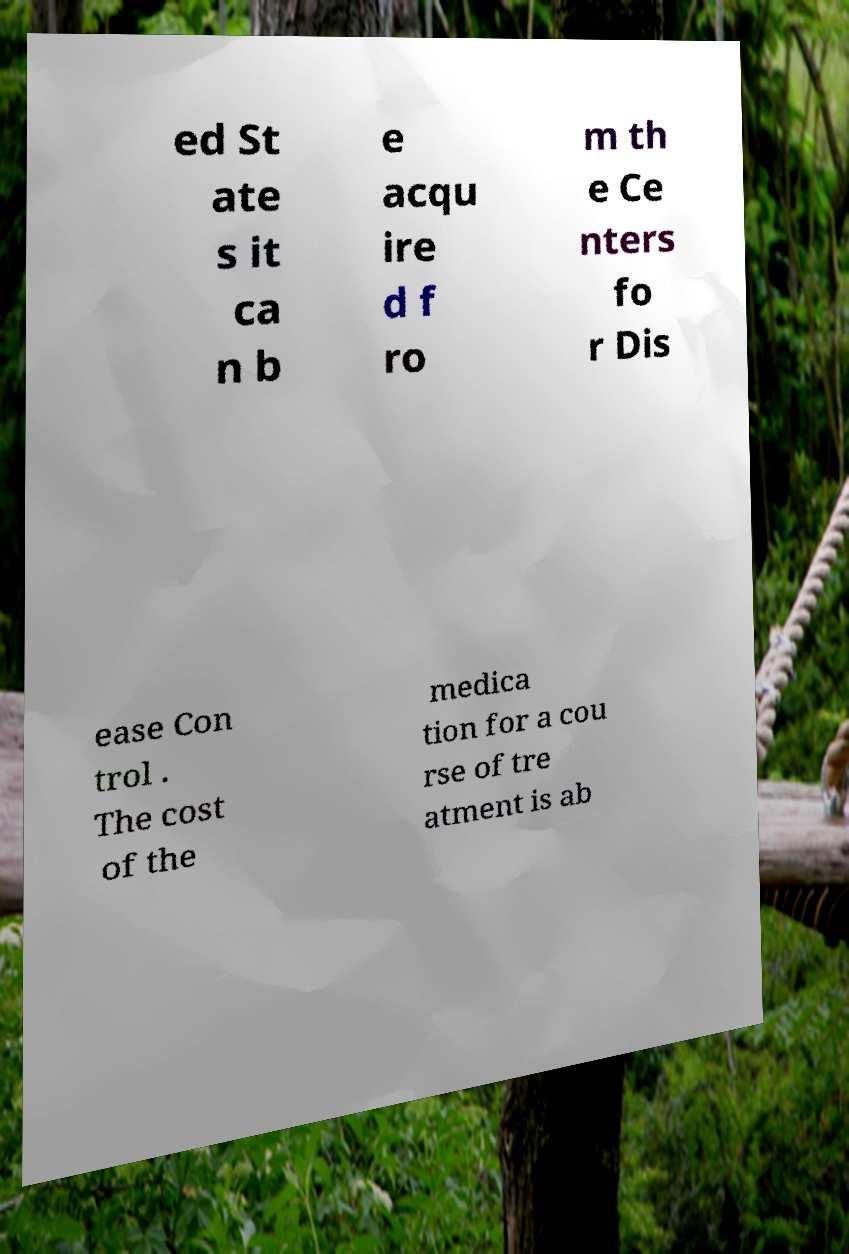I need the written content from this picture converted into text. Can you do that? ed St ate s it ca n b e acqu ire d f ro m th e Ce nters fo r Dis ease Con trol . The cost of the medica tion for a cou rse of tre atment is ab 